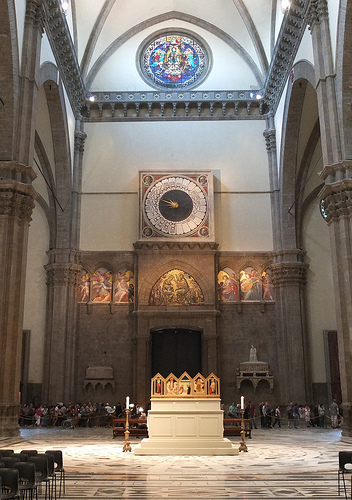What can you tell me about the people in the image? The people in the image appear to be visitors to the cathedral, possibly tourists or worshippers. They are gathered in small groups near the back, some standing, others sitting, suggesting they might be observing or discussing the architecture and art within the space. Describe a possible scenario of their visit in a detailed manner. A group of tourists entered the grand cathedral, their footsteps echoing on the marble floor. Their guide began narrating the rich history of the place, pointing out the intricate details of the frescos and the majestic clock above. One family took a moment to sit in the pews, reflecting on the serene ambiance, while a couple wandered towards the statue on the right, admiring its craftsmanship. Children were fascinated by the stained glass windows, their faces lit up with the colorful light. As they moved around the cathedral, the tourists captured countless photographs, each frame holding a story and the timeless beauty of this architectural marvel. 